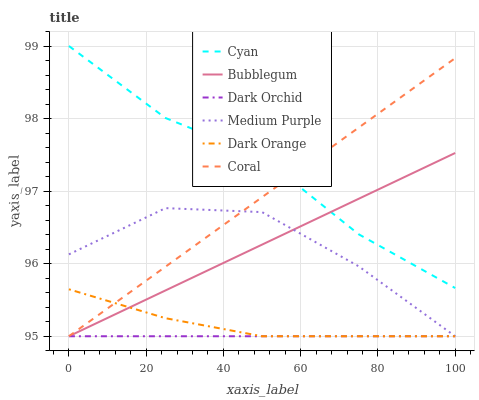Does Dark Orchid have the minimum area under the curve?
Answer yes or no. Yes. Does Cyan have the maximum area under the curve?
Answer yes or no. Yes. Does Coral have the minimum area under the curve?
Answer yes or no. No. Does Coral have the maximum area under the curve?
Answer yes or no. No. Is Coral the smoothest?
Answer yes or no. Yes. Is Medium Purple the roughest?
Answer yes or no. Yes. Is Medium Purple the smoothest?
Answer yes or no. No. Is Dark Orchid the roughest?
Answer yes or no. No. Does Dark Orange have the lowest value?
Answer yes or no. Yes. Does Cyan have the lowest value?
Answer yes or no. No. Does Cyan have the highest value?
Answer yes or no. Yes. Does Coral have the highest value?
Answer yes or no. No. Is Dark Orange less than Cyan?
Answer yes or no. Yes. Is Cyan greater than Dark Orange?
Answer yes or no. Yes. Does Cyan intersect Coral?
Answer yes or no. Yes. Is Cyan less than Coral?
Answer yes or no. No. Is Cyan greater than Coral?
Answer yes or no. No. Does Dark Orange intersect Cyan?
Answer yes or no. No. 